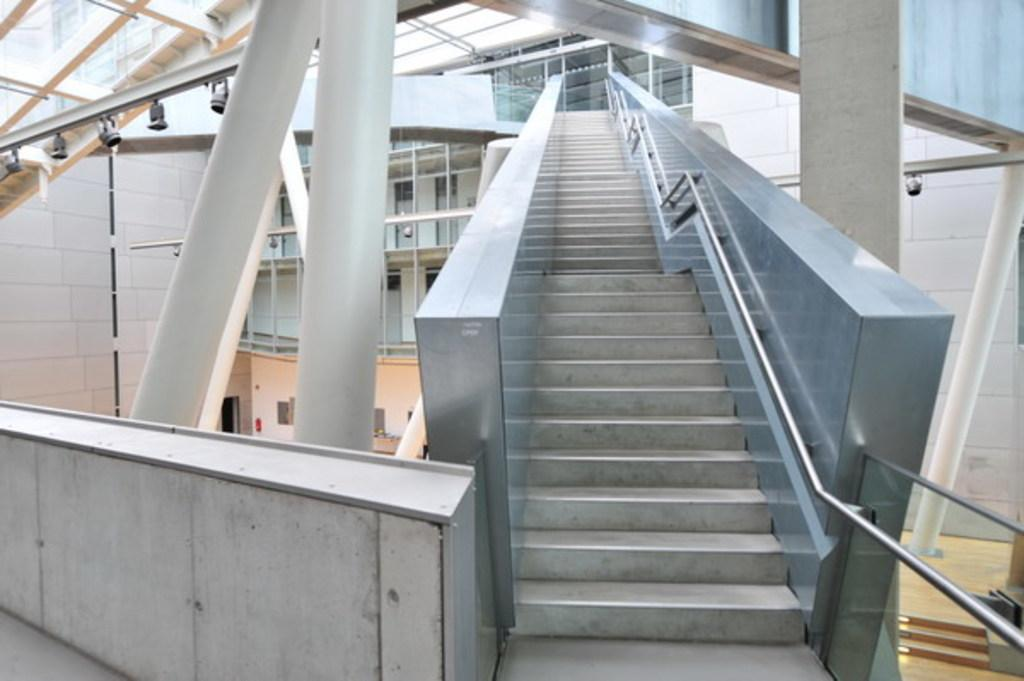What type of structure can be seen in the image? There is a wall, a staircase, and pillars visible in the image. What other elements can be seen in the image? There are rods, pipes, lights, and some objects visible in the image. Can you describe the floor in the image? There is a floor visible on the right side of the image. What type of veil is draped over the staircase in the image? There is no veil present in the image; it features a wall, staircase, pillars, rods, pipes, lights, and objects. How does the learning process take place in the image? The image does not depict a learning process; it is a picture of a wall, staircase, pillars, rods, pipes, lights, and objects. 